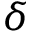<formula> <loc_0><loc_0><loc_500><loc_500>\delta</formula> 